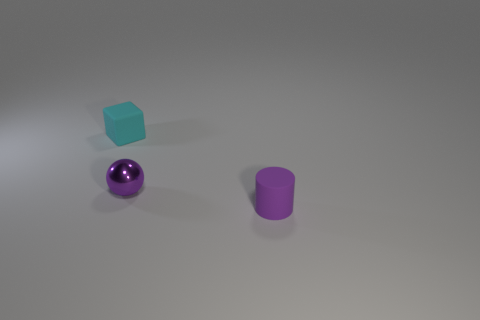Add 2 green spheres. How many objects exist? 5 Add 1 purple metal balls. How many purple metal balls are left? 2 Add 1 tiny gray metallic cubes. How many tiny gray metallic cubes exist? 1 Subtract 0 blue cylinders. How many objects are left? 3 Subtract all spheres. How many objects are left? 2 Subtract 1 spheres. How many spheres are left? 0 Subtract all big yellow balls. Subtract all tiny cyan things. How many objects are left? 2 